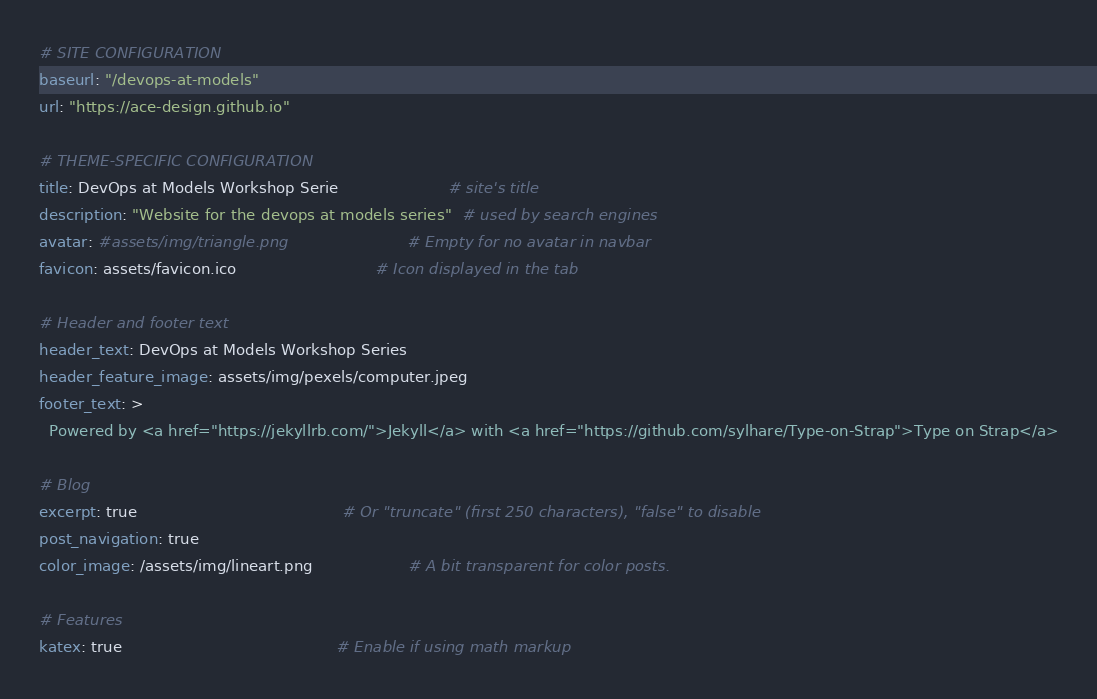Convert code to text. <code><loc_0><loc_0><loc_500><loc_500><_YAML_># SITE CONFIGURATION
baseurl: "/devops-at-models"
url: "https://ace-design.github.io"

# THEME-SPECIFIC CONFIGURATION
title: DevOps at Models Workshop Serie                       # site's title
description: "Website for the devops at models series"  # used by search engines
avatar: #assets/img/triangle.png                         # Empty for no avatar in navbar
favicon: assets/favicon.ico                             # Icon displayed in the tab

# Header and footer text
header_text: DevOps at Models Workshop Series
header_feature_image: assets/img/pexels/computer.jpeg
footer_text: >
  Powered by <a href="https://jekyllrb.com/">Jekyll</a> with <a href="https://github.com/sylhare/Type-on-Strap">Type on Strap</a>

# Blog
excerpt: true                                           # Or "truncate" (first 250 characters), "false" to disable
post_navigation: true
color_image: /assets/img/lineart.png                    # A bit transparent for color posts.

# Features
katex: true                                             # Enable if using math markup</code> 